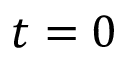Convert formula to latex. <formula><loc_0><loc_0><loc_500><loc_500>t = 0</formula> 